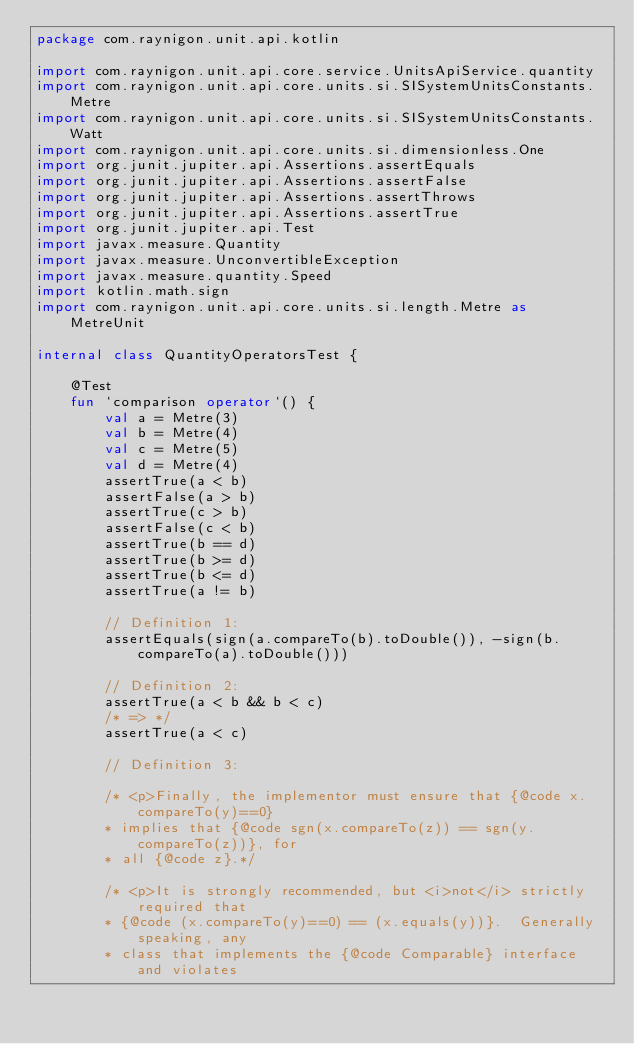<code> <loc_0><loc_0><loc_500><loc_500><_Kotlin_>package com.raynigon.unit.api.kotlin

import com.raynigon.unit.api.core.service.UnitsApiService.quantity
import com.raynigon.unit.api.core.units.si.SISystemUnitsConstants.Metre
import com.raynigon.unit.api.core.units.si.SISystemUnitsConstants.Watt
import com.raynigon.unit.api.core.units.si.dimensionless.One
import org.junit.jupiter.api.Assertions.assertEquals
import org.junit.jupiter.api.Assertions.assertFalse
import org.junit.jupiter.api.Assertions.assertThrows
import org.junit.jupiter.api.Assertions.assertTrue
import org.junit.jupiter.api.Test
import javax.measure.Quantity
import javax.measure.UnconvertibleException
import javax.measure.quantity.Speed
import kotlin.math.sign
import com.raynigon.unit.api.core.units.si.length.Metre as MetreUnit

internal class QuantityOperatorsTest {

    @Test
    fun `comparison operator`() {
        val a = Metre(3)
        val b = Metre(4)
        val c = Metre(5)
        val d = Metre(4)
        assertTrue(a < b)
        assertFalse(a > b)
        assertTrue(c > b)
        assertFalse(c < b)
        assertTrue(b == d)
        assertTrue(b >= d)
        assertTrue(b <= d)
        assertTrue(a != b)

        // Definition 1:
        assertEquals(sign(a.compareTo(b).toDouble()), -sign(b.compareTo(a).toDouble()))

        // Definition 2:
        assertTrue(a < b && b < c)
        /* => */
        assertTrue(a < c)

        // Definition 3:

        /* <p>Finally, the implementor must ensure that {@code x.compareTo(y)==0}
        * implies that {@code sgn(x.compareTo(z)) == sgn(y.compareTo(z))}, for
        * all {@code z}.*/

        /* <p>It is strongly recommended, but <i>not</i> strictly required that
        * {@code (x.compareTo(y)==0) == (x.equals(y))}.  Generally speaking, any
        * class that implements the {@code Comparable} interface and violates</code> 